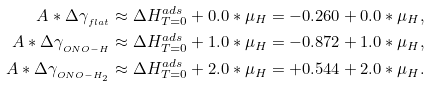<formula> <loc_0><loc_0><loc_500><loc_500>A * \Delta \gamma _ { _ { f l a t } } & \approx \Delta H _ { T = 0 } ^ { a d s } + 0 . 0 * \mu _ { H } = - 0 . 2 6 0 + 0 . 0 * \mu _ { H } , \\ A * \Delta \gamma _ { _ { O N O - H } } & \approx \Delta H _ { T = 0 } ^ { a d s } + 1 . 0 * \mu _ { H } = - 0 . 8 7 2 + 1 . 0 * \mu _ { H } , \\ A * \Delta \gamma _ { _ { O N O - H _ { 2 } } } & \approx \Delta H _ { T = 0 } ^ { a d s } + 2 . 0 * \mu _ { H } = + 0 . 5 4 4 + 2 . 0 * \mu _ { H } .</formula> 